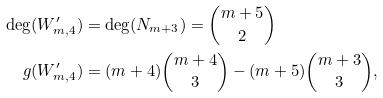<formula> <loc_0><loc_0><loc_500><loc_500>\deg ( W _ { m , 4 } ^ { \prime } ) & = \deg ( N _ { m + 3 } ) = \binom { m + 5 } { 2 } \\ g ( W _ { m , 4 } ^ { \prime } ) & = ( m + 4 ) \binom { m + 4 } { 3 } - ( m + 5 ) \binom { m + 3 } { 3 } ,</formula> 